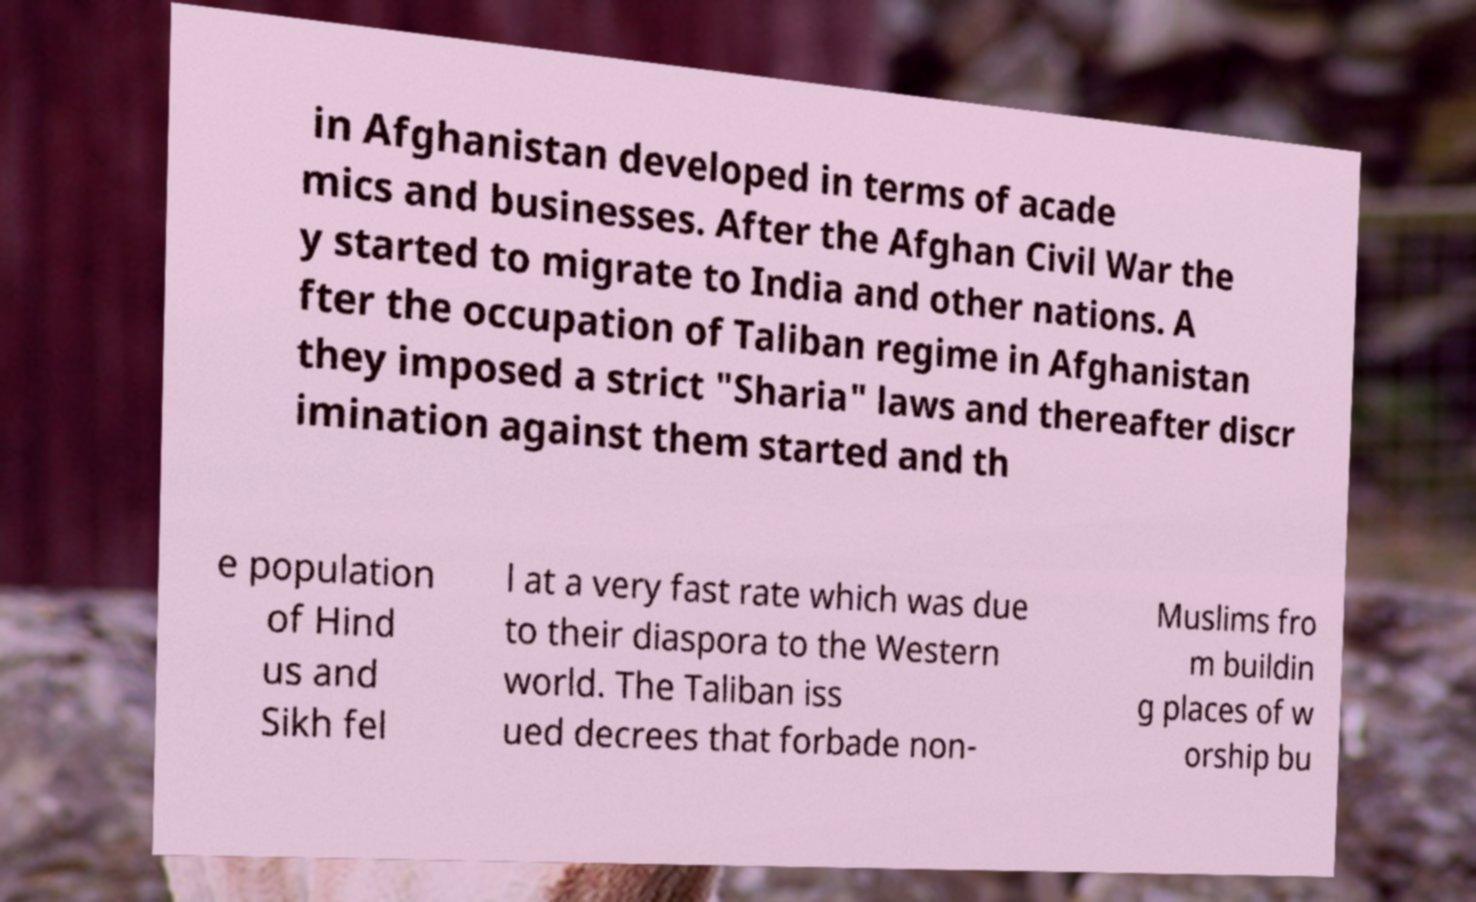There's text embedded in this image that I need extracted. Can you transcribe it verbatim? in Afghanistan developed in terms of acade mics and businesses. After the Afghan Civil War the y started to migrate to India and other nations. A fter the occupation of Taliban regime in Afghanistan they imposed a strict "Sharia" laws and thereafter discr imination against them started and th e population of Hind us and Sikh fel l at a very fast rate which was due to their diaspora to the Western world. The Taliban iss ued decrees that forbade non- Muslims fro m buildin g places of w orship bu 